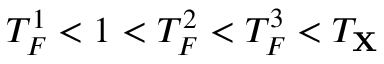Convert formula to latex. <formula><loc_0><loc_0><loc_500><loc_500>T _ { F } ^ { 1 } < 1 < T _ { F } ^ { 2 } < T _ { F } ^ { 3 } < T _ { X }</formula> 